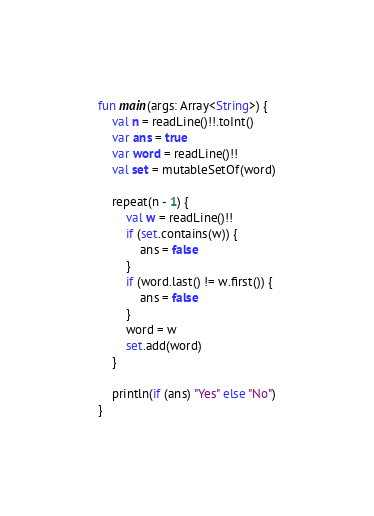Convert code to text. <code><loc_0><loc_0><loc_500><loc_500><_Kotlin_>fun main(args: Array<String>) {
    val n = readLine()!!.toInt()
    var ans = true
    var word = readLine()!!
    val set = mutableSetOf(word)

    repeat(n - 1) {
        val w = readLine()!!
        if (set.contains(w)) {
            ans = false
        }
        if (word.last() != w.first()) {
            ans = false
        }
        word = w
        set.add(word)
    }

    println(if (ans) "Yes" else "No")
}
</code> 